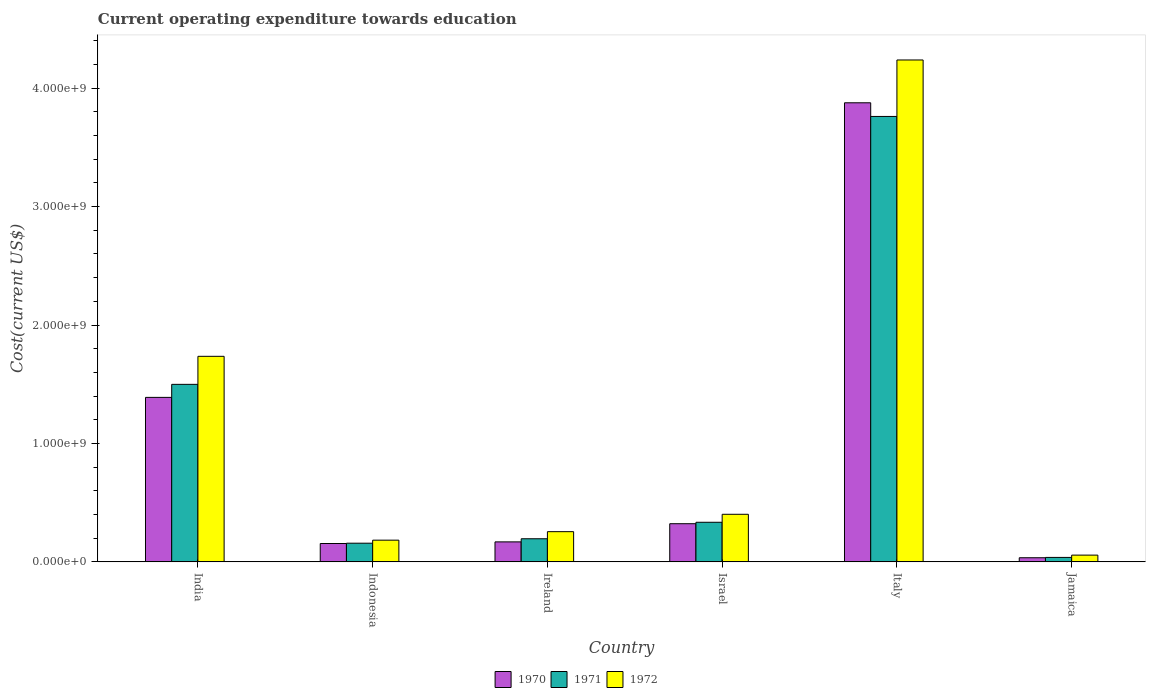How many groups of bars are there?
Your answer should be compact. 6. Are the number of bars on each tick of the X-axis equal?
Offer a terse response. Yes. How many bars are there on the 1st tick from the right?
Keep it short and to the point. 3. What is the label of the 3rd group of bars from the left?
Offer a terse response. Ireland. What is the expenditure towards education in 1972 in Italy?
Keep it short and to the point. 4.24e+09. Across all countries, what is the maximum expenditure towards education in 1971?
Give a very brief answer. 3.76e+09. Across all countries, what is the minimum expenditure towards education in 1972?
Give a very brief answer. 5.71e+07. In which country was the expenditure towards education in 1972 maximum?
Keep it short and to the point. Italy. In which country was the expenditure towards education in 1971 minimum?
Offer a very short reply. Jamaica. What is the total expenditure towards education in 1970 in the graph?
Provide a succinct answer. 5.95e+09. What is the difference between the expenditure towards education in 1971 in Israel and that in Italy?
Make the answer very short. -3.43e+09. What is the difference between the expenditure towards education in 1972 in Ireland and the expenditure towards education in 1971 in Israel?
Offer a very short reply. -7.94e+07. What is the average expenditure towards education in 1970 per country?
Offer a very short reply. 9.91e+08. What is the difference between the expenditure towards education of/in 1970 and expenditure towards education of/in 1972 in Ireland?
Offer a very short reply. -8.62e+07. In how many countries, is the expenditure towards education in 1972 greater than 1400000000 US$?
Give a very brief answer. 2. What is the ratio of the expenditure towards education in 1971 in Israel to that in Italy?
Offer a very short reply. 0.09. Is the difference between the expenditure towards education in 1970 in Indonesia and Italy greater than the difference between the expenditure towards education in 1972 in Indonesia and Italy?
Provide a short and direct response. Yes. What is the difference between the highest and the second highest expenditure towards education in 1971?
Offer a very short reply. 2.26e+09. What is the difference between the highest and the lowest expenditure towards education in 1970?
Your answer should be compact. 3.84e+09. Is the sum of the expenditure towards education in 1970 in India and Indonesia greater than the maximum expenditure towards education in 1971 across all countries?
Provide a short and direct response. No. What does the 1st bar from the left in India represents?
Your response must be concise. 1970. Are all the bars in the graph horizontal?
Your response must be concise. No. How many countries are there in the graph?
Offer a terse response. 6. Where does the legend appear in the graph?
Make the answer very short. Bottom center. How are the legend labels stacked?
Your response must be concise. Horizontal. What is the title of the graph?
Offer a very short reply. Current operating expenditure towards education. What is the label or title of the Y-axis?
Keep it short and to the point. Cost(current US$). What is the Cost(current US$) of 1970 in India?
Ensure brevity in your answer.  1.39e+09. What is the Cost(current US$) of 1971 in India?
Your response must be concise. 1.50e+09. What is the Cost(current US$) of 1972 in India?
Ensure brevity in your answer.  1.74e+09. What is the Cost(current US$) of 1970 in Indonesia?
Offer a terse response. 1.55e+08. What is the Cost(current US$) in 1971 in Indonesia?
Make the answer very short. 1.58e+08. What is the Cost(current US$) in 1972 in Indonesia?
Offer a terse response. 1.83e+08. What is the Cost(current US$) in 1970 in Ireland?
Make the answer very short. 1.69e+08. What is the Cost(current US$) of 1971 in Ireland?
Your answer should be compact. 1.95e+08. What is the Cost(current US$) in 1972 in Ireland?
Your answer should be very brief. 2.55e+08. What is the Cost(current US$) of 1970 in Israel?
Provide a succinct answer. 3.22e+08. What is the Cost(current US$) of 1971 in Israel?
Offer a terse response. 3.34e+08. What is the Cost(current US$) in 1972 in Israel?
Ensure brevity in your answer.  4.02e+08. What is the Cost(current US$) of 1970 in Italy?
Your answer should be compact. 3.88e+09. What is the Cost(current US$) of 1971 in Italy?
Offer a terse response. 3.76e+09. What is the Cost(current US$) in 1972 in Italy?
Your response must be concise. 4.24e+09. What is the Cost(current US$) in 1970 in Jamaica?
Give a very brief answer. 3.49e+07. What is the Cost(current US$) of 1971 in Jamaica?
Your answer should be very brief. 3.77e+07. What is the Cost(current US$) in 1972 in Jamaica?
Give a very brief answer. 5.71e+07. Across all countries, what is the maximum Cost(current US$) of 1970?
Your answer should be very brief. 3.88e+09. Across all countries, what is the maximum Cost(current US$) in 1971?
Make the answer very short. 3.76e+09. Across all countries, what is the maximum Cost(current US$) in 1972?
Ensure brevity in your answer.  4.24e+09. Across all countries, what is the minimum Cost(current US$) of 1970?
Provide a short and direct response. 3.49e+07. Across all countries, what is the minimum Cost(current US$) of 1971?
Make the answer very short. 3.77e+07. Across all countries, what is the minimum Cost(current US$) of 1972?
Provide a succinct answer. 5.71e+07. What is the total Cost(current US$) of 1970 in the graph?
Provide a succinct answer. 5.95e+09. What is the total Cost(current US$) in 1971 in the graph?
Offer a very short reply. 5.99e+09. What is the total Cost(current US$) in 1972 in the graph?
Provide a short and direct response. 6.87e+09. What is the difference between the Cost(current US$) of 1970 in India and that in Indonesia?
Provide a succinct answer. 1.23e+09. What is the difference between the Cost(current US$) in 1971 in India and that in Indonesia?
Keep it short and to the point. 1.34e+09. What is the difference between the Cost(current US$) of 1972 in India and that in Indonesia?
Your response must be concise. 1.55e+09. What is the difference between the Cost(current US$) of 1970 in India and that in Ireland?
Give a very brief answer. 1.22e+09. What is the difference between the Cost(current US$) in 1971 in India and that in Ireland?
Keep it short and to the point. 1.30e+09. What is the difference between the Cost(current US$) in 1972 in India and that in Ireland?
Your answer should be very brief. 1.48e+09. What is the difference between the Cost(current US$) of 1970 in India and that in Israel?
Offer a very short reply. 1.07e+09. What is the difference between the Cost(current US$) of 1971 in India and that in Israel?
Make the answer very short. 1.16e+09. What is the difference between the Cost(current US$) in 1972 in India and that in Israel?
Your answer should be compact. 1.33e+09. What is the difference between the Cost(current US$) of 1970 in India and that in Italy?
Keep it short and to the point. -2.49e+09. What is the difference between the Cost(current US$) in 1971 in India and that in Italy?
Ensure brevity in your answer.  -2.26e+09. What is the difference between the Cost(current US$) in 1972 in India and that in Italy?
Keep it short and to the point. -2.50e+09. What is the difference between the Cost(current US$) in 1970 in India and that in Jamaica?
Provide a short and direct response. 1.35e+09. What is the difference between the Cost(current US$) of 1971 in India and that in Jamaica?
Offer a very short reply. 1.46e+09. What is the difference between the Cost(current US$) in 1972 in India and that in Jamaica?
Keep it short and to the point. 1.68e+09. What is the difference between the Cost(current US$) of 1970 in Indonesia and that in Ireland?
Offer a very short reply. -1.37e+07. What is the difference between the Cost(current US$) in 1971 in Indonesia and that in Ireland?
Give a very brief answer. -3.75e+07. What is the difference between the Cost(current US$) in 1972 in Indonesia and that in Ireland?
Ensure brevity in your answer.  -7.17e+07. What is the difference between the Cost(current US$) of 1970 in Indonesia and that in Israel?
Provide a short and direct response. -1.67e+08. What is the difference between the Cost(current US$) of 1971 in Indonesia and that in Israel?
Offer a terse response. -1.77e+08. What is the difference between the Cost(current US$) in 1972 in Indonesia and that in Israel?
Provide a succinct answer. -2.19e+08. What is the difference between the Cost(current US$) in 1970 in Indonesia and that in Italy?
Give a very brief answer. -3.72e+09. What is the difference between the Cost(current US$) in 1971 in Indonesia and that in Italy?
Offer a very short reply. -3.60e+09. What is the difference between the Cost(current US$) of 1972 in Indonesia and that in Italy?
Give a very brief answer. -4.06e+09. What is the difference between the Cost(current US$) in 1970 in Indonesia and that in Jamaica?
Offer a very short reply. 1.20e+08. What is the difference between the Cost(current US$) of 1971 in Indonesia and that in Jamaica?
Provide a succinct answer. 1.20e+08. What is the difference between the Cost(current US$) of 1972 in Indonesia and that in Jamaica?
Your answer should be compact. 1.26e+08. What is the difference between the Cost(current US$) of 1970 in Ireland and that in Israel?
Provide a short and direct response. -1.53e+08. What is the difference between the Cost(current US$) in 1971 in Ireland and that in Israel?
Make the answer very short. -1.39e+08. What is the difference between the Cost(current US$) in 1972 in Ireland and that in Israel?
Your response must be concise. -1.47e+08. What is the difference between the Cost(current US$) in 1970 in Ireland and that in Italy?
Your answer should be very brief. -3.71e+09. What is the difference between the Cost(current US$) of 1971 in Ireland and that in Italy?
Provide a short and direct response. -3.57e+09. What is the difference between the Cost(current US$) in 1972 in Ireland and that in Italy?
Provide a short and direct response. -3.98e+09. What is the difference between the Cost(current US$) of 1970 in Ireland and that in Jamaica?
Give a very brief answer. 1.34e+08. What is the difference between the Cost(current US$) of 1971 in Ireland and that in Jamaica?
Offer a very short reply. 1.57e+08. What is the difference between the Cost(current US$) in 1972 in Ireland and that in Jamaica?
Give a very brief answer. 1.98e+08. What is the difference between the Cost(current US$) in 1970 in Israel and that in Italy?
Keep it short and to the point. -3.55e+09. What is the difference between the Cost(current US$) in 1971 in Israel and that in Italy?
Your response must be concise. -3.43e+09. What is the difference between the Cost(current US$) of 1972 in Israel and that in Italy?
Your response must be concise. -3.84e+09. What is the difference between the Cost(current US$) in 1970 in Israel and that in Jamaica?
Your answer should be compact. 2.87e+08. What is the difference between the Cost(current US$) in 1971 in Israel and that in Jamaica?
Your answer should be compact. 2.97e+08. What is the difference between the Cost(current US$) in 1972 in Israel and that in Jamaica?
Offer a very short reply. 3.45e+08. What is the difference between the Cost(current US$) of 1970 in Italy and that in Jamaica?
Your response must be concise. 3.84e+09. What is the difference between the Cost(current US$) of 1971 in Italy and that in Jamaica?
Make the answer very short. 3.72e+09. What is the difference between the Cost(current US$) in 1972 in Italy and that in Jamaica?
Your answer should be very brief. 4.18e+09. What is the difference between the Cost(current US$) of 1970 in India and the Cost(current US$) of 1971 in Indonesia?
Give a very brief answer. 1.23e+09. What is the difference between the Cost(current US$) in 1970 in India and the Cost(current US$) in 1972 in Indonesia?
Give a very brief answer. 1.21e+09. What is the difference between the Cost(current US$) in 1971 in India and the Cost(current US$) in 1972 in Indonesia?
Give a very brief answer. 1.32e+09. What is the difference between the Cost(current US$) in 1970 in India and the Cost(current US$) in 1971 in Ireland?
Offer a very short reply. 1.19e+09. What is the difference between the Cost(current US$) of 1970 in India and the Cost(current US$) of 1972 in Ireland?
Make the answer very short. 1.13e+09. What is the difference between the Cost(current US$) of 1971 in India and the Cost(current US$) of 1972 in Ireland?
Give a very brief answer. 1.24e+09. What is the difference between the Cost(current US$) in 1970 in India and the Cost(current US$) in 1971 in Israel?
Offer a very short reply. 1.05e+09. What is the difference between the Cost(current US$) in 1970 in India and the Cost(current US$) in 1972 in Israel?
Keep it short and to the point. 9.87e+08. What is the difference between the Cost(current US$) in 1971 in India and the Cost(current US$) in 1972 in Israel?
Offer a terse response. 1.10e+09. What is the difference between the Cost(current US$) of 1970 in India and the Cost(current US$) of 1971 in Italy?
Your response must be concise. -2.37e+09. What is the difference between the Cost(current US$) in 1970 in India and the Cost(current US$) in 1972 in Italy?
Keep it short and to the point. -2.85e+09. What is the difference between the Cost(current US$) in 1971 in India and the Cost(current US$) in 1972 in Italy?
Provide a succinct answer. -2.74e+09. What is the difference between the Cost(current US$) in 1970 in India and the Cost(current US$) in 1971 in Jamaica?
Your answer should be compact. 1.35e+09. What is the difference between the Cost(current US$) of 1970 in India and the Cost(current US$) of 1972 in Jamaica?
Make the answer very short. 1.33e+09. What is the difference between the Cost(current US$) in 1971 in India and the Cost(current US$) in 1972 in Jamaica?
Make the answer very short. 1.44e+09. What is the difference between the Cost(current US$) in 1970 in Indonesia and the Cost(current US$) in 1971 in Ireland?
Keep it short and to the point. -4.00e+07. What is the difference between the Cost(current US$) in 1970 in Indonesia and the Cost(current US$) in 1972 in Ireland?
Make the answer very short. -9.99e+07. What is the difference between the Cost(current US$) of 1971 in Indonesia and the Cost(current US$) of 1972 in Ireland?
Offer a terse response. -9.74e+07. What is the difference between the Cost(current US$) in 1970 in Indonesia and the Cost(current US$) in 1971 in Israel?
Ensure brevity in your answer.  -1.79e+08. What is the difference between the Cost(current US$) in 1970 in Indonesia and the Cost(current US$) in 1972 in Israel?
Your response must be concise. -2.47e+08. What is the difference between the Cost(current US$) of 1971 in Indonesia and the Cost(current US$) of 1972 in Israel?
Keep it short and to the point. -2.44e+08. What is the difference between the Cost(current US$) of 1970 in Indonesia and the Cost(current US$) of 1971 in Italy?
Offer a terse response. -3.61e+09. What is the difference between the Cost(current US$) in 1970 in Indonesia and the Cost(current US$) in 1972 in Italy?
Provide a succinct answer. -4.08e+09. What is the difference between the Cost(current US$) in 1971 in Indonesia and the Cost(current US$) in 1972 in Italy?
Your answer should be compact. -4.08e+09. What is the difference between the Cost(current US$) of 1970 in Indonesia and the Cost(current US$) of 1971 in Jamaica?
Provide a short and direct response. 1.17e+08. What is the difference between the Cost(current US$) of 1970 in Indonesia and the Cost(current US$) of 1972 in Jamaica?
Your answer should be compact. 9.81e+07. What is the difference between the Cost(current US$) in 1971 in Indonesia and the Cost(current US$) in 1972 in Jamaica?
Offer a terse response. 1.01e+08. What is the difference between the Cost(current US$) of 1970 in Ireland and the Cost(current US$) of 1971 in Israel?
Offer a very short reply. -1.66e+08. What is the difference between the Cost(current US$) in 1970 in Ireland and the Cost(current US$) in 1972 in Israel?
Make the answer very short. -2.33e+08. What is the difference between the Cost(current US$) of 1971 in Ireland and the Cost(current US$) of 1972 in Israel?
Ensure brevity in your answer.  -2.07e+08. What is the difference between the Cost(current US$) in 1970 in Ireland and the Cost(current US$) in 1971 in Italy?
Provide a short and direct response. -3.59e+09. What is the difference between the Cost(current US$) of 1970 in Ireland and the Cost(current US$) of 1972 in Italy?
Keep it short and to the point. -4.07e+09. What is the difference between the Cost(current US$) in 1971 in Ireland and the Cost(current US$) in 1972 in Italy?
Your answer should be compact. -4.04e+09. What is the difference between the Cost(current US$) in 1970 in Ireland and the Cost(current US$) in 1971 in Jamaica?
Your answer should be compact. 1.31e+08. What is the difference between the Cost(current US$) in 1970 in Ireland and the Cost(current US$) in 1972 in Jamaica?
Provide a succinct answer. 1.12e+08. What is the difference between the Cost(current US$) in 1971 in Ireland and the Cost(current US$) in 1972 in Jamaica?
Keep it short and to the point. 1.38e+08. What is the difference between the Cost(current US$) in 1970 in Israel and the Cost(current US$) in 1971 in Italy?
Your response must be concise. -3.44e+09. What is the difference between the Cost(current US$) in 1970 in Israel and the Cost(current US$) in 1972 in Italy?
Your response must be concise. -3.92e+09. What is the difference between the Cost(current US$) of 1971 in Israel and the Cost(current US$) of 1972 in Italy?
Offer a terse response. -3.90e+09. What is the difference between the Cost(current US$) in 1970 in Israel and the Cost(current US$) in 1971 in Jamaica?
Your response must be concise. 2.85e+08. What is the difference between the Cost(current US$) of 1970 in Israel and the Cost(current US$) of 1972 in Jamaica?
Ensure brevity in your answer.  2.65e+08. What is the difference between the Cost(current US$) of 1971 in Israel and the Cost(current US$) of 1972 in Jamaica?
Your answer should be very brief. 2.77e+08. What is the difference between the Cost(current US$) in 1970 in Italy and the Cost(current US$) in 1971 in Jamaica?
Provide a succinct answer. 3.84e+09. What is the difference between the Cost(current US$) of 1970 in Italy and the Cost(current US$) of 1972 in Jamaica?
Make the answer very short. 3.82e+09. What is the difference between the Cost(current US$) of 1971 in Italy and the Cost(current US$) of 1972 in Jamaica?
Provide a succinct answer. 3.70e+09. What is the average Cost(current US$) in 1970 per country?
Offer a terse response. 9.91e+08. What is the average Cost(current US$) in 1971 per country?
Offer a terse response. 9.98e+08. What is the average Cost(current US$) of 1972 per country?
Keep it short and to the point. 1.15e+09. What is the difference between the Cost(current US$) of 1970 and Cost(current US$) of 1971 in India?
Offer a very short reply. -1.10e+08. What is the difference between the Cost(current US$) of 1970 and Cost(current US$) of 1972 in India?
Ensure brevity in your answer.  -3.47e+08. What is the difference between the Cost(current US$) of 1971 and Cost(current US$) of 1972 in India?
Your answer should be compact. -2.37e+08. What is the difference between the Cost(current US$) of 1970 and Cost(current US$) of 1971 in Indonesia?
Provide a short and direct response. -2.54e+06. What is the difference between the Cost(current US$) of 1970 and Cost(current US$) of 1972 in Indonesia?
Provide a succinct answer. -2.82e+07. What is the difference between the Cost(current US$) of 1971 and Cost(current US$) of 1972 in Indonesia?
Keep it short and to the point. -2.56e+07. What is the difference between the Cost(current US$) in 1970 and Cost(current US$) in 1971 in Ireland?
Ensure brevity in your answer.  -2.64e+07. What is the difference between the Cost(current US$) of 1970 and Cost(current US$) of 1972 in Ireland?
Your answer should be compact. -8.62e+07. What is the difference between the Cost(current US$) in 1971 and Cost(current US$) in 1972 in Ireland?
Your answer should be very brief. -5.99e+07. What is the difference between the Cost(current US$) of 1970 and Cost(current US$) of 1971 in Israel?
Ensure brevity in your answer.  -1.22e+07. What is the difference between the Cost(current US$) of 1970 and Cost(current US$) of 1972 in Israel?
Make the answer very short. -7.96e+07. What is the difference between the Cost(current US$) of 1971 and Cost(current US$) of 1972 in Israel?
Provide a short and direct response. -6.74e+07. What is the difference between the Cost(current US$) in 1970 and Cost(current US$) in 1971 in Italy?
Offer a very short reply. 1.15e+08. What is the difference between the Cost(current US$) of 1970 and Cost(current US$) of 1972 in Italy?
Your response must be concise. -3.62e+08. What is the difference between the Cost(current US$) in 1971 and Cost(current US$) in 1972 in Italy?
Your answer should be compact. -4.77e+08. What is the difference between the Cost(current US$) in 1970 and Cost(current US$) in 1971 in Jamaica?
Your answer should be compact. -2.78e+06. What is the difference between the Cost(current US$) in 1970 and Cost(current US$) in 1972 in Jamaica?
Your response must be concise. -2.22e+07. What is the difference between the Cost(current US$) of 1971 and Cost(current US$) of 1972 in Jamaica?
Provide a succinct answer. -1.94e+07. What is the ratio of the Cost(current US$) in 1970 in India to that in Indonesia?
Keep it short and to the point. 8.95. What is the ratio of the Cost(current US$) of 1971 in India to that in Indonesia?
Your answer should be compact. 9.51. What is the ratio of the Cost(current US$) of 1972 in India to that in Indonesia?
Ensure brevity in your answer.  9.47. What is the ratio of the Cost(current US$) of 1970 in India to that in Ireland?
Provide a succinct answer. 8.23. What is the ratio of the Cost(current US$) of 1971 in India to that in Ireland?
Offer a very short reply. 7.68. What is the ratio of the Cost(current US$) in 1972 in India to that in Ireland?
Provide a short and direct response. 6.81. What is the ratio of the Cost(current US$) in 1970 in India to that in Israel?
Your answer should be compact. 4.31. What is the ratio of the Cost(current US$) of 1971 in India to that in Israel?
Provide a short and direct response. 4.48. What is the ratio of the Cost(current US$) of 1972 in India to that in Israel?
Give a very brief answer. 4.32. What is the ratio of the Cost(current US$) in 1970 in India to that in Italy?
Your answer should be very brief. 0.36. What is the ratio of the Cost(current US$) of 1971 in India to that in Italy?
Give a very brief answer. 0.4. What is the ratio of the Cost(current US$) in 1972 in India to that in Italy?
Provide a short and direct response. 0.41. What is the ratio of the Cost(current US$) in 1970 in India to that in Jamaica?
Give a very brief answer. 39.76. What is the ratio of the Cost(current US$) of 1971 in India to that in Jamaica?
Your answer should be compact. 39.75. What is the ratio of the Cost(current US$) of 1972 in India to that in Jamaica?
Keep it short and to the point. 30.39. What is the ratio of the Cost(current US$) of 1970 in Indonesia to that in Ireland?
Your response must be concise. 0.92. What is the ratio of the Cost(current US$) in 1971 in Indonesia to that in Ireland?
Your response must be concise. 0.81. What is the ratio of the Cost(current US$) of 1972 in Indonesia to that in Ireland?
Ensure brevity in your answer.  0.72. What is the ratio of the Cost(current US$) in 1970 in Indonesia to that in Israel?
Give a very brief answer. 0.48. What is the ratio of the Cost(current US$) in 1971 in Indonesia to that in Israel?
Your answer should be compact. 0.47. What is the ratio of the Cost(current US$) of 1972 in Indonesia to that in Israel?
Provide a short and direct response. 0.46. What is the ratio of the Cost(current US$) of 1971 in Indonesia to that in Italy?
Provide a succinct answer. 0.04. What is the ratio of the Cost(current US$) of 1972 in Indonesia to that in Italy?
Offer a terse response. 0.04. What is the ratio of the Cost(current US$) in 1970 in Indonesia to that in Jamaica?
Your answer should be compact. 4.44. What is the ratio of the Cost(current US$) of 1971 in Indonesia to that in Jamaica?
Your answer should be compact. 4.18. What is the ratio of the Cost(current US$) in 1972 in Indonesia to that in Jamaica?
Keep it short and to the point. 3.21. What is the ratio of the Cost(current US$) in 1970 in Ireland to that in Israel?
Provide a succinct answer. 0.52. What is the ratio of the Cost(current US$) of 1971 in Ireland to that in Israel?
Your answer should be compact. 0.58. What is the ratio of the Cost(current US$) in 1972 in Ireland to that in Israel?
Offer a terse response. 0.63. What is the ratio of the Cost(current US$) of 1970 in Ireland to that in Italy?
Your answer should be compact. 0.04. What is the ratio of the Cost(current US$) of 1971 in Ireland to that in Italy?
Offer a very short reply. 0.05. What is the ratio of the Cost(current US$) in 1972 in Ireland to that in Italy?
Keep it short and to the point. 0.06. What is the ratio of the Cost(current US$) of 1970 in Ireland to that in Jamaica?
Keep it short and to the point. 4.83. What is the ratio of the Cost(current US$) in 1971 in Ireland to that in Jamaica?
Provide a succinct answer. 5.18. What is the ratio of the Cost(current US$) in 1972 in Ireland to that in Jamaica?
Offer a very short reply. 4.47. What is the ratio of the Cost(current US$) of 1970 in Israel to that in Italy?
Keep it short and to the point. 0.08. What is the ratio of the Cost(current US$) of 1971 in Israel to that in Italy?
Give a very brief answer. 0.09. What is the ratio of the Cost(current US$) of 1972 in Israel to that in Italy?
Provide a short and direct response. 0.09. What is the ratio of the Cost(current US$) in 1970 in Israel to that in Jamaica?
Offer a very short reply. 9.22. What is the ratio of the Cost(current US$) of 1971 in Israel to that in Jamaica?
Provide a short and direct response. 8.87. What is the ratio of the Cost(current US$) in 1972 in Israel to that in Jamaica?
Provide a short and direct response. 7.04. What is the ratio of the Cost(current US$) in 1970 in Italy to that in Jamaica?
Offer a terse response. 110.97. What is the ratio of the Cost(current US$) in 1971 in Italy to that in Jamaica?
Make the answer very short. 99.73. What is the ratio of the Cost(current US$) of 1972 in Italy to that in Jamaica?
Keep it short and to the point. 74.21. What is the difference between the highest and the second highest Cost(current US$) of 1970?
Offer a terse response. 2.49e+09. What is the difference between the highest and the second highest Cost(current US$) in 1971?
Ensure brevity in your answer.  2.26e+09. What is the difference between the highest and the second highest Cost(current US$) in 1972?
Your response must be concise. 2.50e+09. What is the difference between the highest and the lowest Cost(current US$) of 1970?
Provide a succinct answer. 3.84e+09. What is the difference between the highest and the lowest Cost(current US$) of 1971?
Provide a short and direct response. 3.72e+09. What is the difference between the highest and the lowest Cost(current US$) of 1972?
Provide a succinct answer. 4.18e+09. 